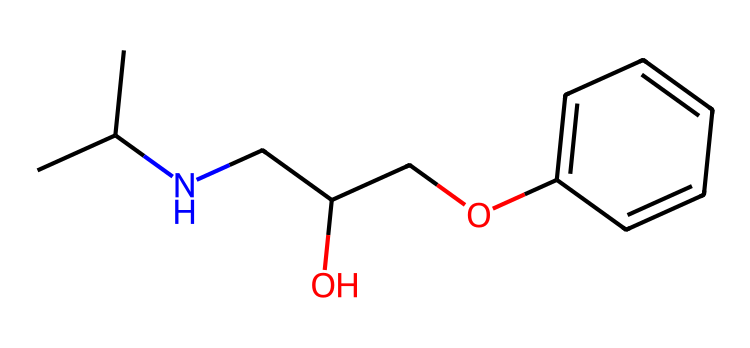What is the total number of carbon atoms in this chemical? By examining the SMILES representation, we can count the number of carbon atoms. The notation CC(C) indicates three carbon atoms in that fragment alone. Other parts also contain additional carbon atoms represented by "c" (which denotes sp2 hybridized carbon in aromatic systems). So, we have the sum: 4 from the branched structure and 6 from the phenyl ring, totaling 10 carbon atoms.
Answer: 10 How many hydroxyl groups (–OH) are present in the structure? In the SMILES representation, the "O" in "CC(O)" indicates a hydroxyl group is present. Additionally, there is another "O" in "CO" indicating another hydroxyl group. Therefore, counting these gives us a total of 2 hydroxyl groups.
Answer: 2 What functional group is indicated by the "N" in this compound? The presence of "N" in the SMILES signifies an amine group. Specifically, it is likely a secondary amine considering that it is attached to two carbon groups in the structure. Hence, the functional group associated with "N" is an amine.
Answer: amine What distinguishes the chemical nature of this compound as a beta-blocker? The presence of an aromatic ring and the amine function (secondary) highlights its properties and structural clues linking it to the beta-blocker class of medications. Beta-blockers typically work by blocking beta-adrenergic receptors, which this structure supports.
Answer: beta-blocker What type of bond connects the carbon atoms in the side chain? In examining the structure, the connections between the carbon atoms in the aliphatic chain segment and the ring show single bonds (represented simply as C-C). These bonds are standard sigma bonds, typical in alkyl chains.
Answer: single bond How does this compound's structure suggest its mechanism of action concerning heart medications? The structure includes hydrophobic regions (the phenyl ring and aliphatic chain) and hydrophilic regions (hydroxyl groups), which indicate its ability to interact with both lipid membranes and the aqueous environment, a key feature for heart medications that necessitate receptor binding and modulation.
Answer: receptor binding 